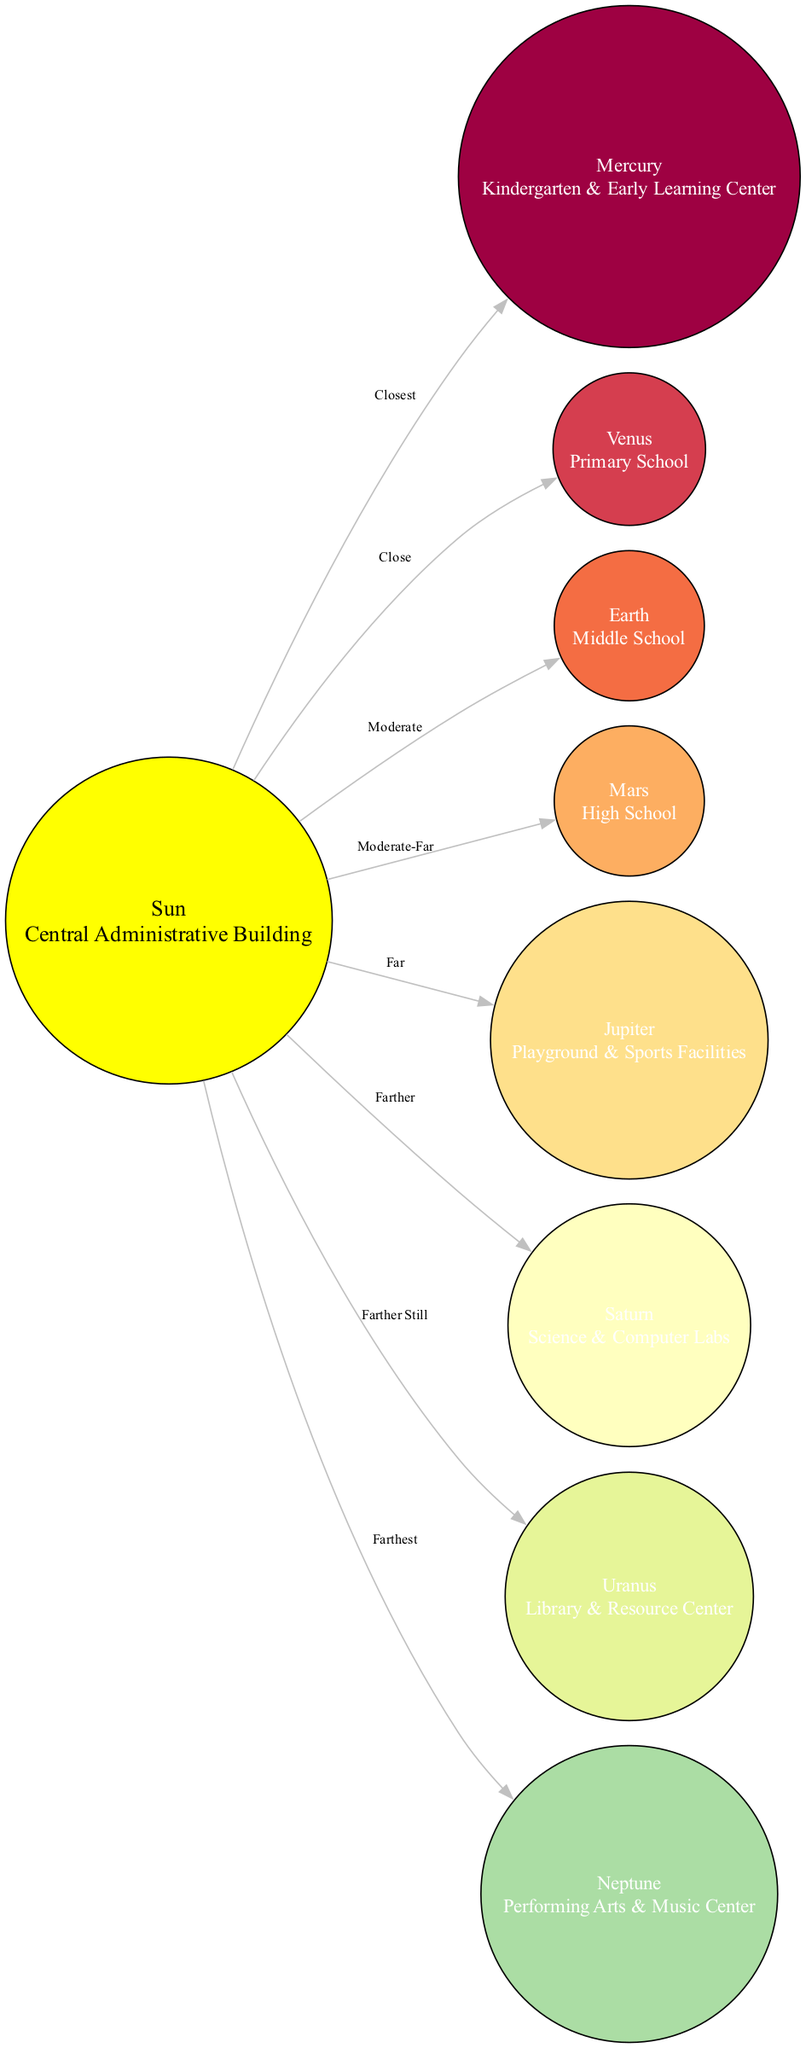What is the central star of the diagram? The diagram identifies the central star as the "Sun," which represents the Central Administrative Building.
Answer: Sun Which facility is closest to the Sun? According to the diagram, the closest facility to the Sun is Mercury, which represents the Kindergarten & Early Learning Center.
Answer: Kindergarten & Early Learning Center What is the distance from the Sun to Mars? The diagram indicates that the distance from the Sun to Mars is classified as "Moderate-Far."
Answer: Moderate-Far How many planets are represented in the diagram? The diagram shows a total of eight planets, each corresponding to different school facilities, including the central star.
Answer: Eight What facility is represented by Jupiter? In the diagram, Jupiter represents the Playground & Sports Facilities.
Answer: Playground & Sports Facilities Which facility is farthest from the Sun? The furthest facility from the Sun in the diagram is Neptune, which stands for the Performing Arts & Music Center.
Answer: Performing Arts & Music Center What facility is represented by Uranus? According to the diagram, Uranus represents the Library & Resource Center.
Answer: Library & Resource Center What is the relationship between the Primary School and the Middle School in terms of distance from the Sun? The distance from the Sun to Venus (Primary School) is "Close," while the distance to Earth (Middle School) is "Moderate," indicating that the Primary School is closer to the Sun than the Middle School.
Answer: Closer Which facility has the same distance from the Sun as Saturn? The facility that shares the same distance from the Sun as Saturn (Science & Computer Labs) is Uranus (Library & Resource Center), both categorized as "Farther Still."
Answer: Library & Resource Center 